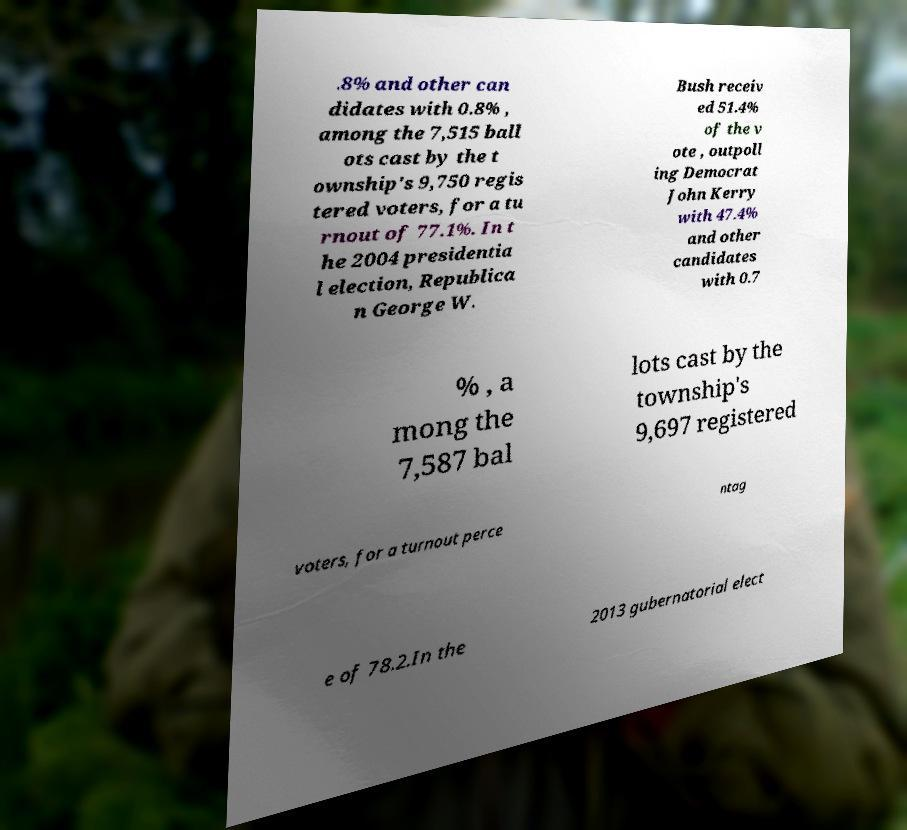Could you assist in decoding the text presented in this image and type it out clearly? .8% and other can didates with 0.8% , among the 7,515 ball ots cast by the t ownship's 9,750 regis tered voters, for a tu rnout of 77.1%. In t he 2004 presidentia l election, Republica n George W. Bush receiv ed 51.4% of the v ote , outpoll ing Democrat John Kerry with 47.4% and other candidates with 0.7 % , a mong the 7,587 bal lots cast by the township's 9,697 registered voters, for a turnout perce ntag e of 78.2.In the 2013 gubernatorial elect 